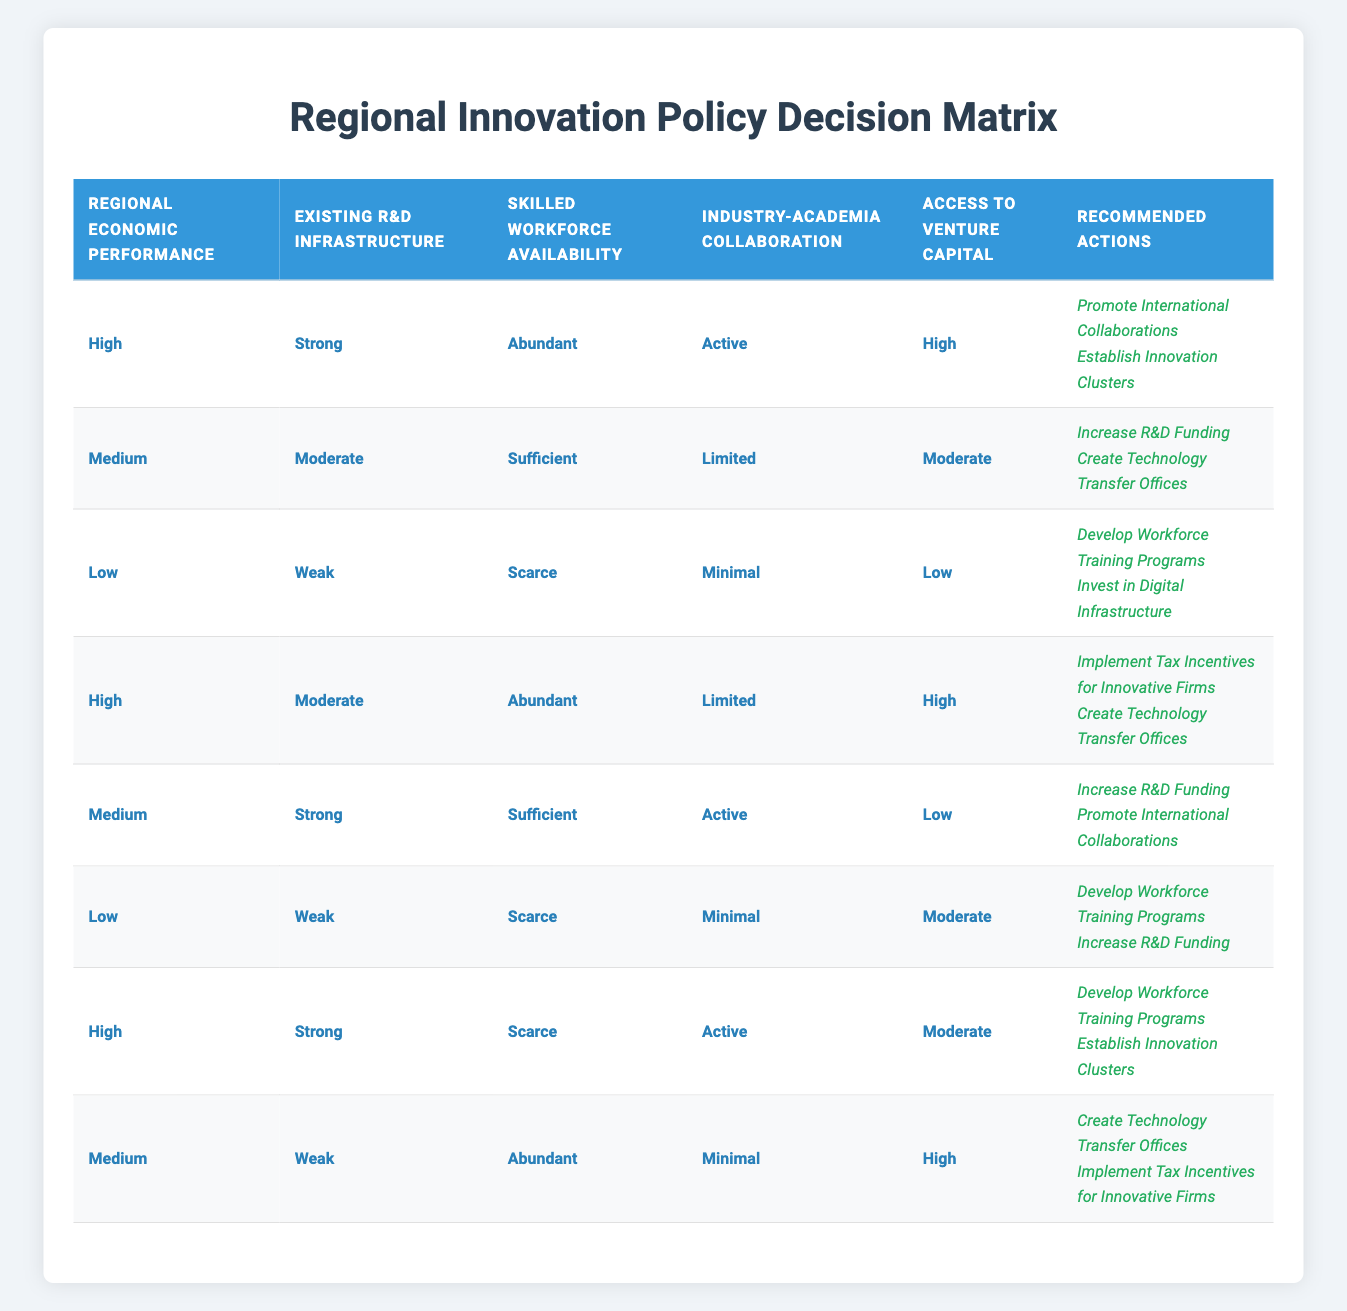What actions are recommended when the regional economic performance is low, with weak R&D infrastructure and a scarce skilled workforce? Referring to the table, the row that matches these conditions (Low, Weak, Scarce) suggests the actions to take are "Develop Workforce Training Programs" and "Invest in Digital Infrastructure."
Answer: Develop Workforce Training Programs, Invest in Digital Infrastructure Are there any recommended actions when there is a high access to venture capital and strong existing R&D infrastructure? Looking at the table, the conditions of high access to venture capital and strong existing R&D infrastructure appear in multiple rows. One row lists the actions as "Promote International Collaborations" and "Establish Innovation Clusters", and another row with moderate access proposes "Implement Tax Incentives for Innovative Firms" and "Create Technology Transfer Offices." However, the actions differ based on the other conditions.
Answer: Yes How many total recommended actions are there when the conditions indicate a medium regional economic performance and limited industry-academia collaboration? There is one relevant row that matches these conditions (Medium, Moderate, Sufficient, Limited, Moderate). It suggests two actions: "Increase R&D Funding" and "Create Technology Transfer Offices." Therefore, there are 2 total actions in this scenario.
Answer: 2 Is it true that promoting international collaborations is recommended for regions that are high in R&D infrastructure and have a scarce skilled workforce? Analyzing the table, the specified conditions (High, Strong, Scarce) align with the actions of "Develop Workforce Training Programs" and "Establish Innovation Clusters." However, "Promote International Collaborations" does not appear; hence, the statement is false.
Answer: No What is the result when the region has medium economic performance, strong R&D infrastructure, and active industry-academia collaboration? According to the table, there is a row with the conditions (Medium, Strong, Sufficient, Active) which refers to "Increase R&D Funding" and "Promote International Collaborations" as the recommended actions, so these actions are the result for the given conditions.
Answer: Increase R&D Funding, Promote International Collaborations 